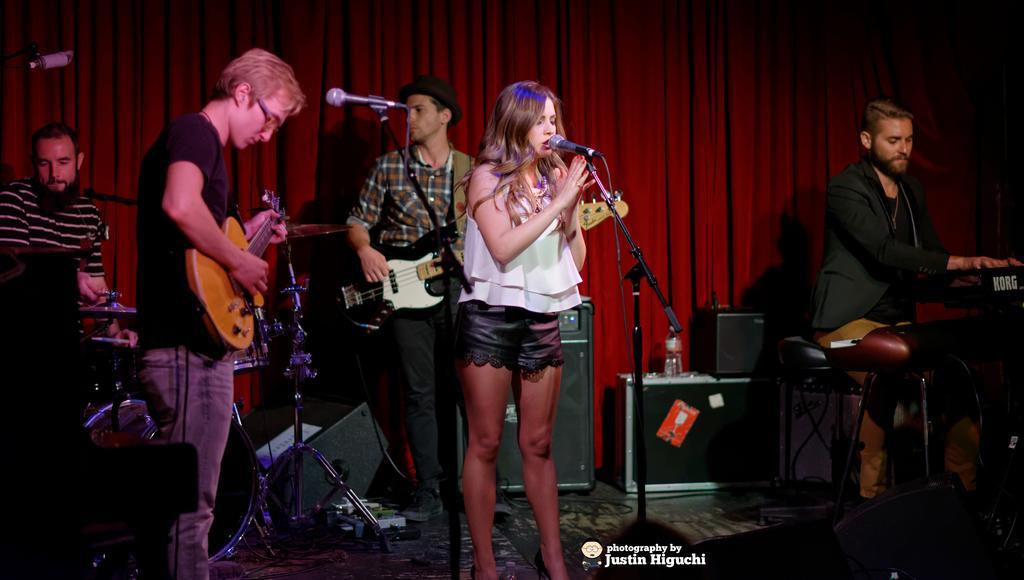Could you give a brief overview of what you see in this image? In this picture there is a girl in the center of the image and there is a mic in front of her and there is a man who is playing piano on the right side of the image and there is a man on the left side of the image, it seems to be, he is playing drum set and there are two men on the left side of the image, by holding guitars in their hands and there are speakers in the image and there is a red color curtain in the background area of the image, it seems to be a suitcase in the background area of the image. 